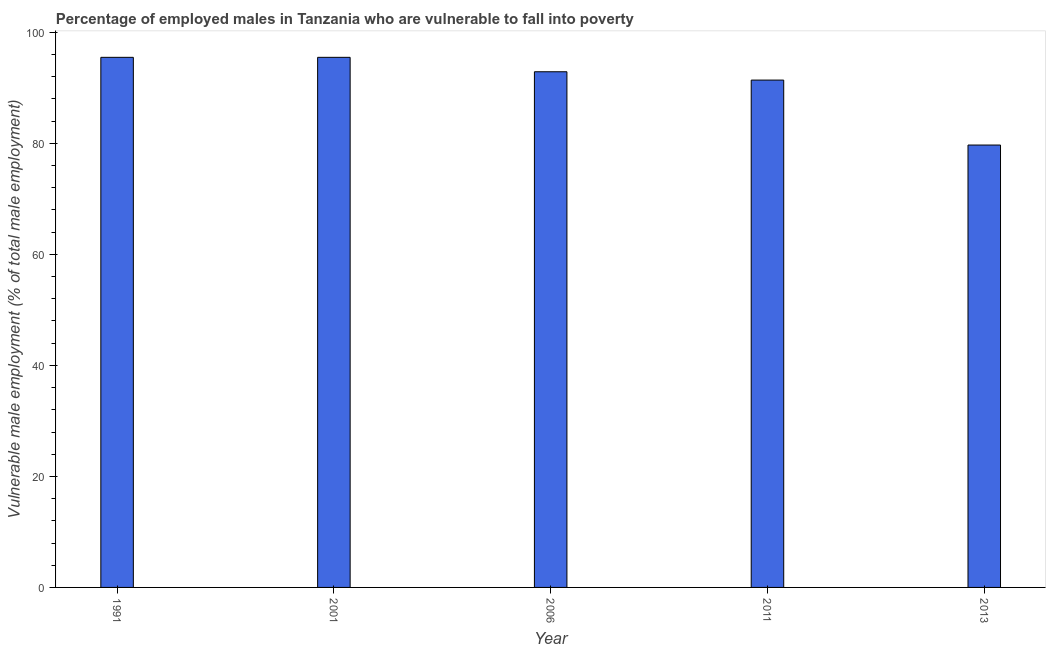Does the graph contain any zero values?
Provide a succinct answer. No. Does the graph contain grids?
Provide a short and direct response. No. What is the title of the graph?
Offer a very short reply. Percentage of employed males in Tanzania who are vulnerable to fall into poverty. What is the label or title of the Y-axis?
Offer a very short reply. Vulnerable male employment (% of total male employment). What is the percentage of employed males who are vulnerable to fall into poverty in 2001?
Offer a very short reply. 95.5. Across all years, what is the maximum percentage of employed males who are vulnerable to fall into poverty?
Give a very brief answer. 95.5. Across all years, what is the minimum percentage of employed males who are vulnerable to fall into poverty?
Provide a succinct answer. 79.7. In which year was the percentage of employed males who are vulnerable to fall into poverty maximum?
Your answer should be compact. 1991. What is the sum of the percentage of employed males who are vulnerable to fall into poverty?
Ensure brevity in your answer.  455. What is the difference between the percentage of employed males who are vulnerable to fall into poverty in 2006 and 2013?
Your answer should be compact. 13.2. What is the average percentage of employed males who are vulnerable to fall into poverty per year?
Provide a short and direct response. 91. What is the median percentage of employed males who are vulnerable to fall into poverty?
Your answer should be very brief. 92.9. What is the ratio of the percentage of employed males who are vulnerable to fall into poverty in 2011 to that in 2013?
Offer a terse response. 1.15. Is the percentage of employed males who are vulnerable to fall into poverty in 2001 less than that in 2006?
Your answer should be very brief. No. What is the difference between the highest and the second highest percentage of employed males who are vulnerable to fall into poverty?
Offer a very short reply. 0. Are all the bars in the graph horizontal?
Ensure brevity in your answer.  No. How many years are there in the graph?
Offer a very short reply. 5. What is the difference between two consecutive major ticks on the Y-axis?
Your answer should be very brief. 20. What is the Vulnerable male employment (% of total male employment) of 1991?
Keep it short and to the point. 95.5. What is the Vulnerable male employment (% of total male employment) of 2001?
Your response must be concise. 95.5. What is the Vulnerable male employment (% of total male employment) in 2006?
Your response must be concise. 92.9. What is the Vulnerable male employment (% of total male employment) in 2011?
Your answer should be compact. 91.4. What is the Vulnerable male employment (% of total male employment) of 2013?
Offer a very short reply. 79.7. What is the difference between the Vulnerable male employment (% of total male employment) in 1991 and 2006?
Your response must be concise. 2.6. What is the difference between the Vulnerable male employment (% of total male employment) in 1991 and 2011?
Offer a terse response. 4.1. What is the difference between the Vulnerable male employment (% of total male employment) in 1991 and 2013?
Offer a terse response. 15.8. What is the difference between the Vulnerable male employment (% of total male employment) in 2006 and 2013?
Give a very brief answer. 13.2. What is the ratio of the Vulnerable male employment (% of total male employment) in 1991 to that in 2001?
Provide a short and direct response. 1. What is the ratio of the Vulnerable male employment (% of total male employment) in 1991 to that in 2006?
Make the answer very short. 1.03. What is the ratio of the Vulnerable male employment (% of total male employment) in 1991 to that in 2011?
Keep it short and to the point. 1.04. What is the ratio of the Vulnerable male employment (% of total male employment) in 1991 to that in 2013?
Your answer should be compact. 1.2. What is the ratio of the Vulnerable male employment (% of total male employment) in 2001 to that in 2006?
Your answer should be very brief. 1.03. What is the ratio of the Vulnerable male employment (% of total male employment) in 2001 to that in 2011?
Offer a very short reply. 1.04. What is the ratio of the Vulnerable male employment (% of total male employment) in 2001 to that in 2013?
Your response must be concise. 1.2. What is the ratio of the Vulnerable male employment (% of total male employment) in 2006 to that in 2011?
Ensure brevity in your answer.  1.02. What is the ratio of the Vulnerable male employment (% of total male employment) in 2006 to that in 2013?
Your response must be concise. 1.17. What is the ratio of the Vulnerable male employment (% of total male employment) in 2011 to that in 2013?
Offer a very short reply. 1.15. 